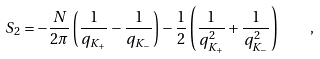Convert formula to latex. <formula><loc_0><loc_0><loc_500><loc_500>S _ { 2 } = - \frac { N } { 2 \pi } \left ( \frac { 1 } { q _ { K _ { + } } } - \frac { 1 } { q _ { K _ { - } } } \right ) - \frac { 1 } { 2 } \left ( \frac { 1 } { q ^ { 2 } _ { K _ { + } } } + \frac { 1 } { q ^ { 2 } _ { K _ { - } } } \right ) \quad ,</formula> 